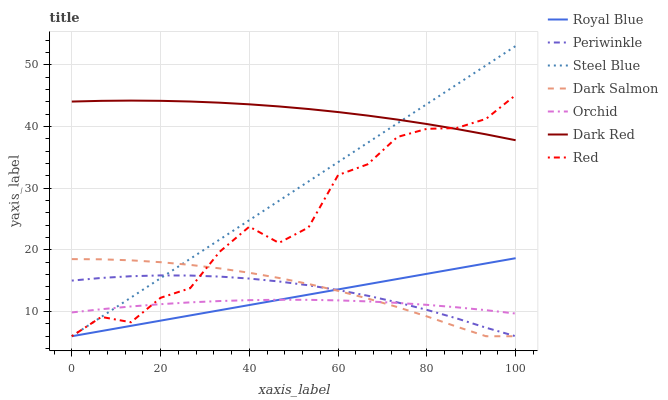Does Orchid have the minimum area under the curve?
Answer yes or no. Yes. Does Dark Red have the maximum area under the curve?
Answer yes or no. Yes. Does Steel Blue have the minimum area under the curve?
Answer yes or no. No. Does Steel Blue have the maximum area under the curve?
Answer yes or no. No. Is Steel Blue the smoothest?
Answer yes or no. Yes. Is Red the roughest?
Answer yes or no. Yes. Is Dark Salmon the smoothest?
Answer yes or no. No. Is Dark Salmon the roughest?
Answer yes or no. No. Does Orchid have the lowest value?
Answer yes or no. No. Does Steel Blue have the highest value?
Answer yes or no. Yes. Does Dark Salmon have the highest value?
Answer yes or no. No. Is Dark Salmon less than Dark Red?
Answer yes or no. Yes. Is Dark Red greater than Orchid?
Answer yes or no. Yes. Does Red intersect Orchid?
Answer yes or no. Yes. Is Red less than Orchid?
Answer yes or no. No. Is Red greater than Orchid?
Answer yes or no. No. Does Dark Salmon intersect Dark Red?
Answer yes or no. No. 